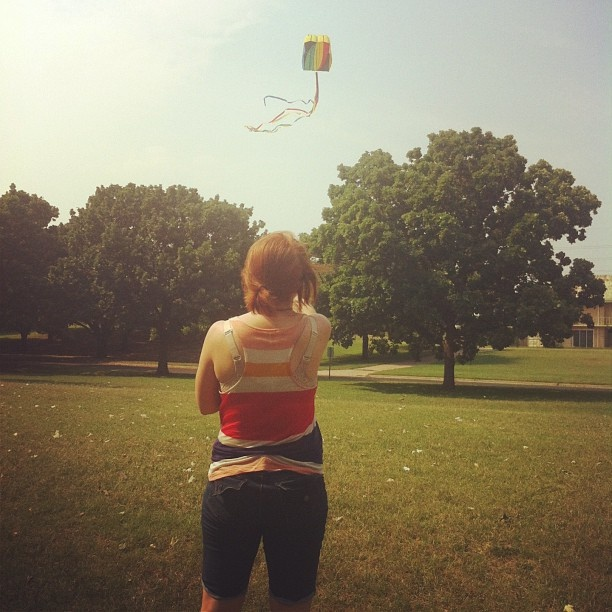Describe the objects in this image and their specific colors. I can see people in ivory, black, gray, maroon, and brown tones and kite in ivory, tan, darkgray, and khaki tones in this image. 